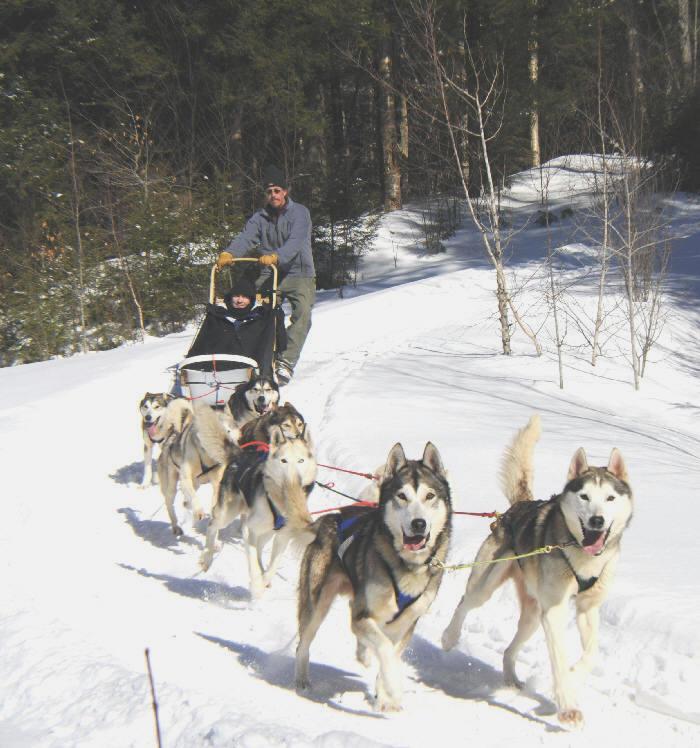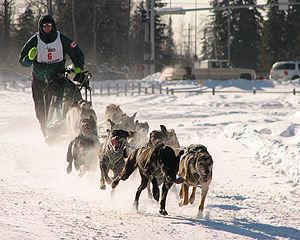The first image is the image on the left, the second image is the image on the right. Analyze the images presented: Is the assertion "In one image, dog sleds are traveling close to and between large snow covered trees." valid? Answer yes or no. No. The first image is the image on the left, the second image is the image on the right. Assess this claim about the two images: "In both images, the sled dogs are heading in nearly the same direction.". Correct or not? Answer yes or no. Yes. 